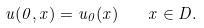Convert formula to latex. <formula><loc_0><loc_0><loc_500><loc_500>u ( 0 , x ) = u _ { 0 } ( x ) \quad x \in D .</formula> 